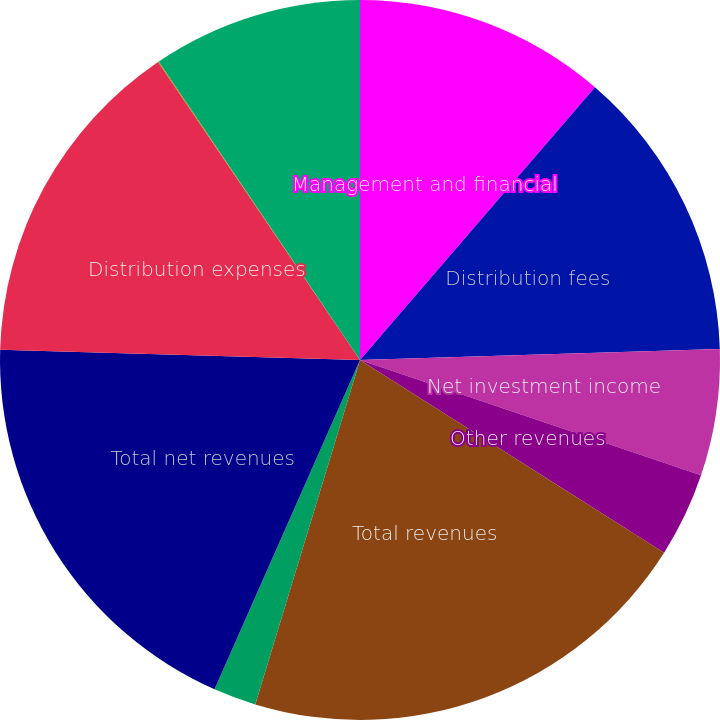<chart> <loc_0><loc_0><loc_500><loc_500><pie_chart><fcel>Management and financial<fcel>Distribution fees<fcel>Net investment income<fcel>Other revenues<fcel>Total revenues<fcel>Banking and deposit interest<fcel>Total net revenues<fcel>Distribution expenses<fcel>Interest and debt expense<fcel>General and administrative<nl><fcel>11.32%<fcel>13.19%<fcel>5.68%<fcel>3.8%<fcel>20.71%<fcel>1.92%<fcel>18.83%<fcel>15.07%<fcel>0.04%<fcel>9.44%<nl></chart> 